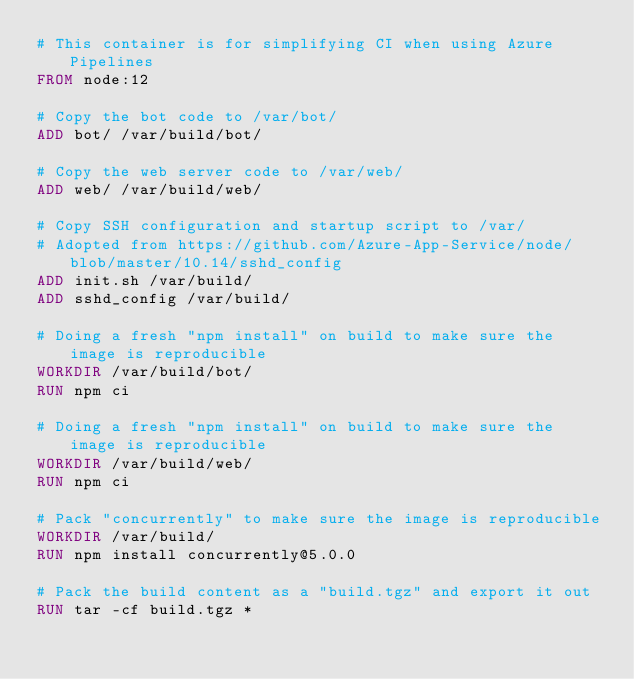Convert code to text. <code><loc_0><loc_0><loc_500><loc_500><_Dockerfile_># This container is for simplifying CI when using Azure Pipelines
FROM node:12

# Copy the bot code to /var/bot/
ADD bot/ /var/build/bot/

# Copy the web server code to /var/web/
ADD web/ /var/build/web/

# Copy SSH configuration and startup script to /var/
# Adopted from https://github.com/Azure-App-Service/node/blob/master/10.14/sshd_config
ADD init.sh /var/build/
ADD sshd_config /var/build/

# Doing a fresh "npm install" on build to make sure the image is reproducible
WORKDIR /var/build/bot/
RUN npm ci

# Doing a fresh "npm install" on build to make sure the image is reproducible
WORKDIR /var/build/web/
RUN npm ci

# Pack "concurrently" to make sure the image is reproducible
WORKDIR /var/build/
RUN npm install concurrently@5.0.0

# Pack the build content as a "build.tgz" and export it out
RUN tar -cf build.tgz *
</code> 